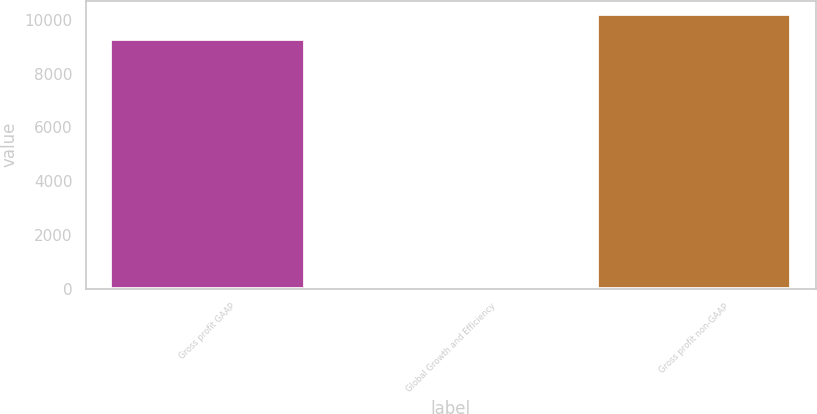Convert chart to OTSL. <chart><loc_0><loc_0><loc_500><loc_500><bar_chart><fcel>Gross profit GAAP<fcel>Global Growth and Efficiency<fcel>Gross profit non-GAAP<nl><fcel>9280<fcel>75<fcel>10208<nl></chart> 